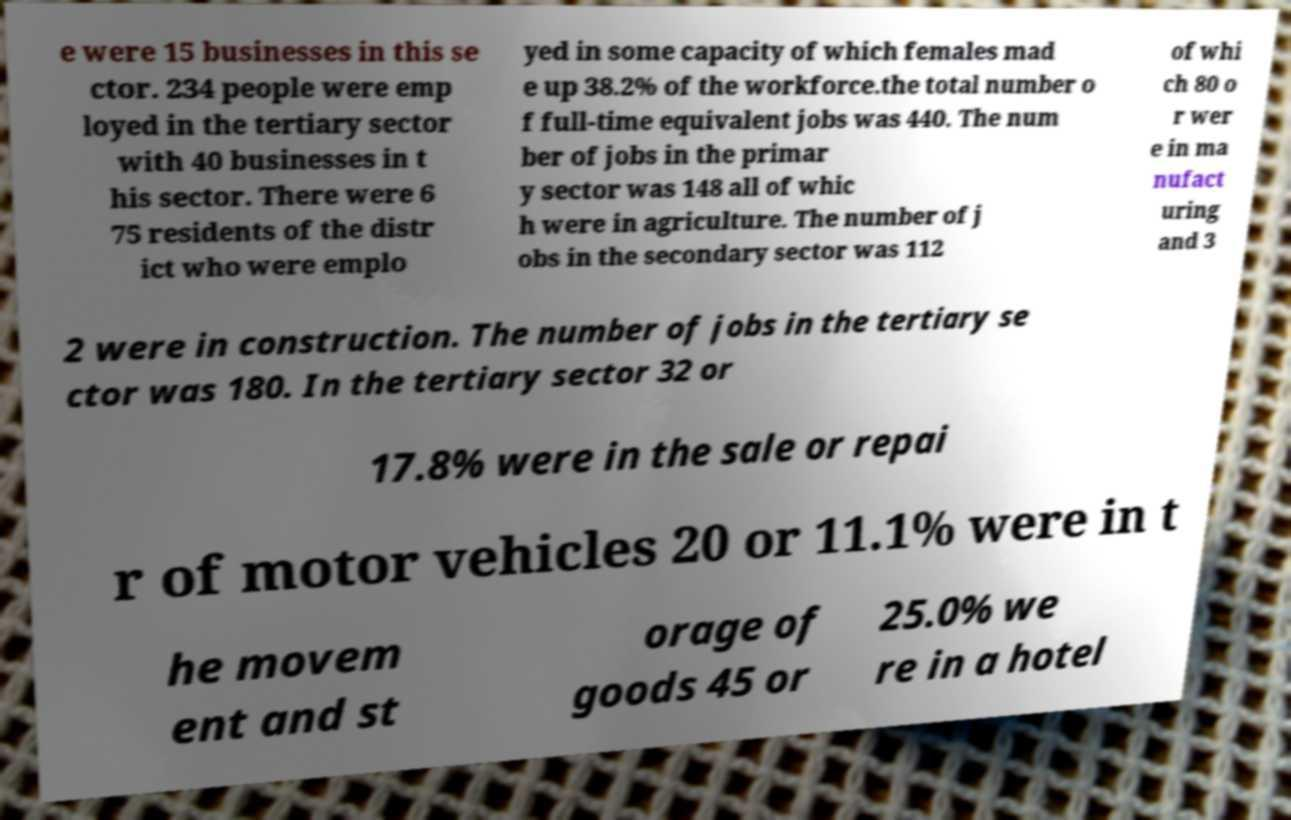Could you extract and type out the text from this image? e were 15 businesses in this se ctor. 234 people were emp loyed in the tertiary sector with 40 businesses in t his sector. There were 6 75 residents of the distr ict who were emplo yed in some capacity of which females mad e up 38.2% of the workforce.the total number o f full-time equivalent jobs was 440. The num ber of jobs in the primar y sector was 148 all of whic h were in agriculture. The number of j obs in the secondary sector was 112 of whi ch 80 o r wer e in ma nufact uring and 3 2 were in construction. The number of jobs in the tertiary se ctor was 180. In the tertiary sector 32 or 17.8% were in the sale or repai r of motor vehicles 20 or 11.1% were in t he movem ent and st orage of goods 45 or 25.0% we re in a hotel 